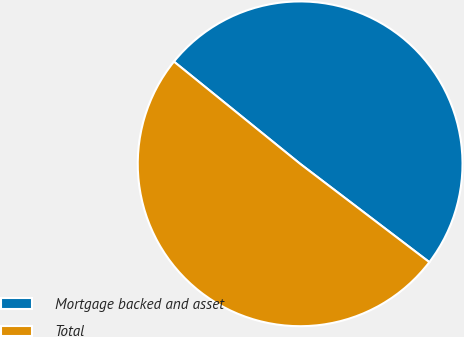Convert chart. <chart><loc_0><loc_0><loc_500><loc_500><pie_chart><fcel>Mortgage backed and asset<fcel>Total<nl><fcel>49.52%<fcel>50.48%<nl></chart> 